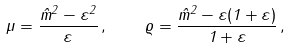Convert formula to latex. <formula><loc_0><loc_0><loc_500><loc_500>\mu = \frac { \hat { m } ^ { 2 } - \varepsilon ^ { 2 } } { \varepsilon } \, , \quad \varrho = \frac { \hat { m } ^ { 2 } - \varepsilon ( 1 + \varepsilon ) } { 1 + \varepsilon } \, ,</formula> 